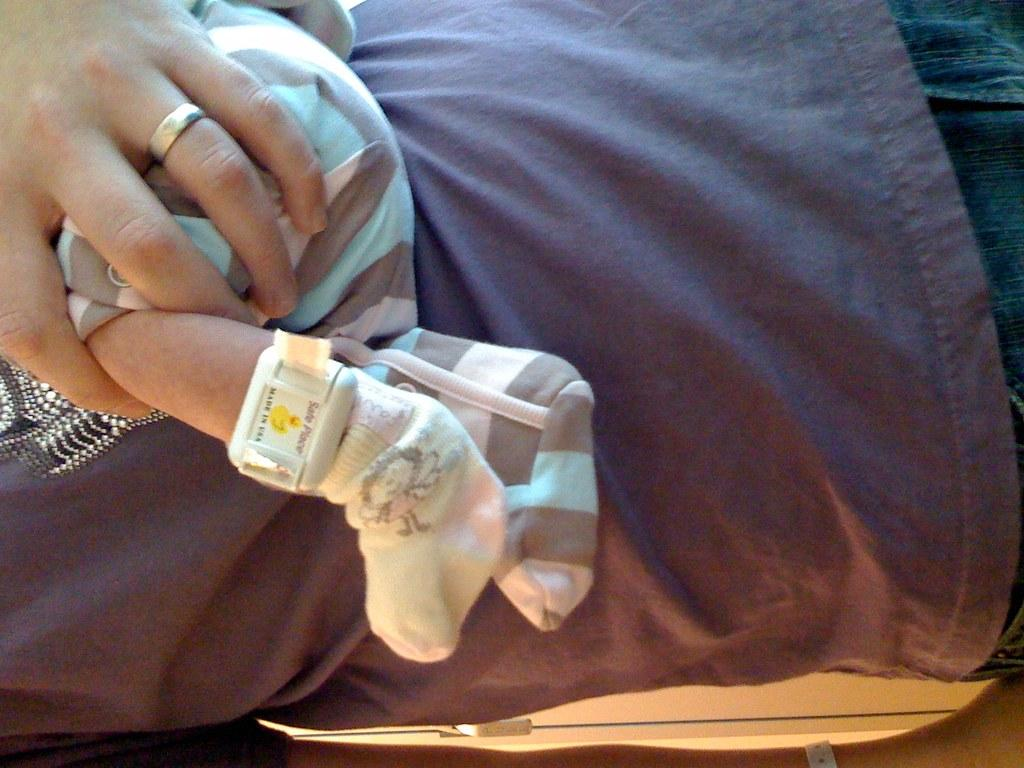What is the main subject of the image? There is a person standing in the image. What is the person doing in the image? The person is carrying a baby. Can you describe any accessories the person is wearing? The person has a ring on one of their fingers. Reasoning: Let' Let's think step by step in order to produce the conversation. We start by identifying the main subject of the image, which is the person standing. Then, we describe what the person is doing, which is carrying a baby. Finally, we mention any accessories the person is wearing, which is a ring on one of their fingers. Absurd Question/Answer: What side of the person is the baby being carried on? The image does not specify which side of the person the baby is being carried on. What part of the day is depicted in the image? The image does not provide any information about the time of day. What part of the person's body is the ring located on? The image does not specify which finger the ring is on. What type of day is it in the image? The image does not provide any information about the weather or the type of day. 